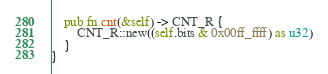Convert code to text. <code><loc_0><loc_0><loc_500><loc_500><_Rust_>    pub fn cnt(&self) -> CNT_R {
        CNT_R::new((self.bits & 0x00ff_ffff) as u32)
    }
}
</code> 